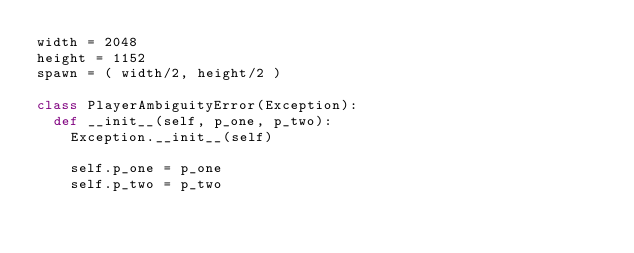Convert code to text. <code><loc_0><loc_0><loc_500><loc_500><_Python_>width = 2048
height = 1152
spawn = ( width/2, height/2 )

class PlayerAmbiguityError(Exception):
	def __init__(self, p_one, p_two):
		Exception.__init__(self)

		self.p_one = p_one
		self.p_two = p_two
</code> 